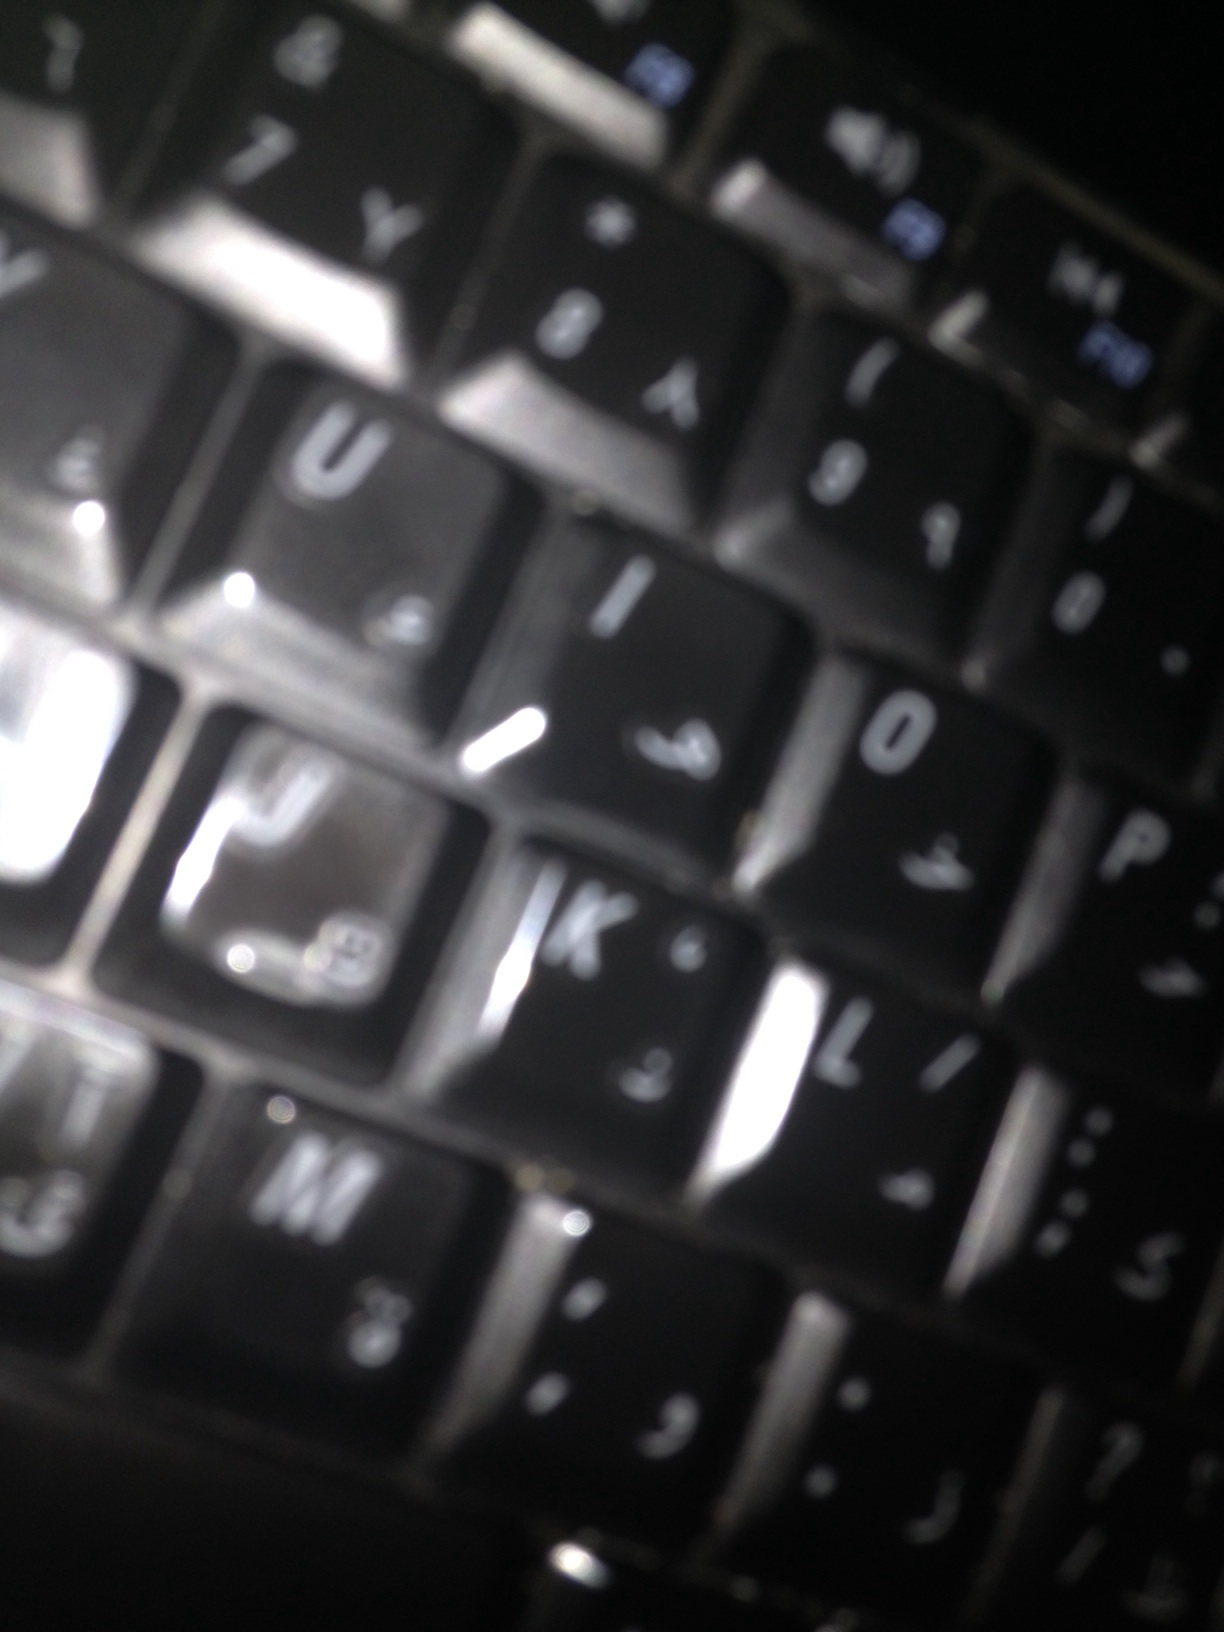Describe a superhero who uses this keyboard as their primary tool. The superhero 'KeyMaster' uses this specialized keyboard to access almost any digital system in the world. With unparalleled typing speed and accuracy, KeyMaster can decode encrypted messages, hack into villainous organizations, and send critical information to allies in split seconds. The keyboard glows with each keystroke, and the bilingual layout allows KeyMaster to communicate with international contacts effortlessly. This essential tool is not just for typing; it also serves as a direct interface to a powerful, custom-built AI assistant. KeyMaster is able to navigate through virtual threats and safeguard digital realms with the power of their keyboard! 